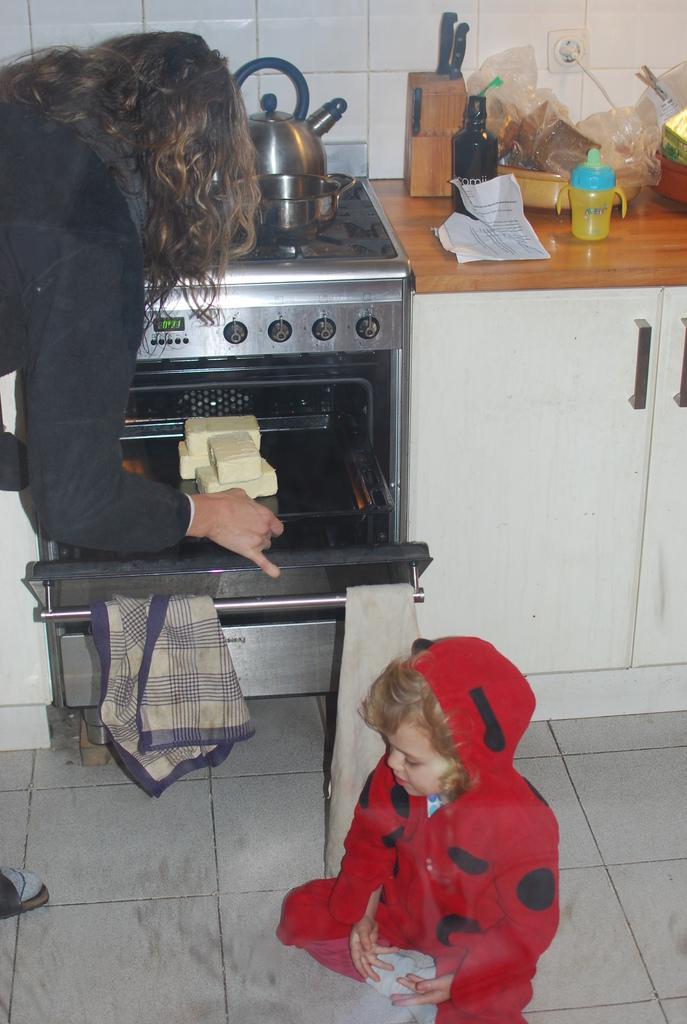Describe this image in one or two sentences. In this image we can see a boy is sitting on the floor. He is wearing red color dress. In the middle of the image we can see a cupboard, countertop, stove, oven and cloth. On the countertop, knife bottle, bowls and things are there. Left side of the image, one lady is there. She is wearing black color dress and keeping some food item in the oven. On the stove we can see the pan and kettle. At the top of the image we can see tiled walls. 